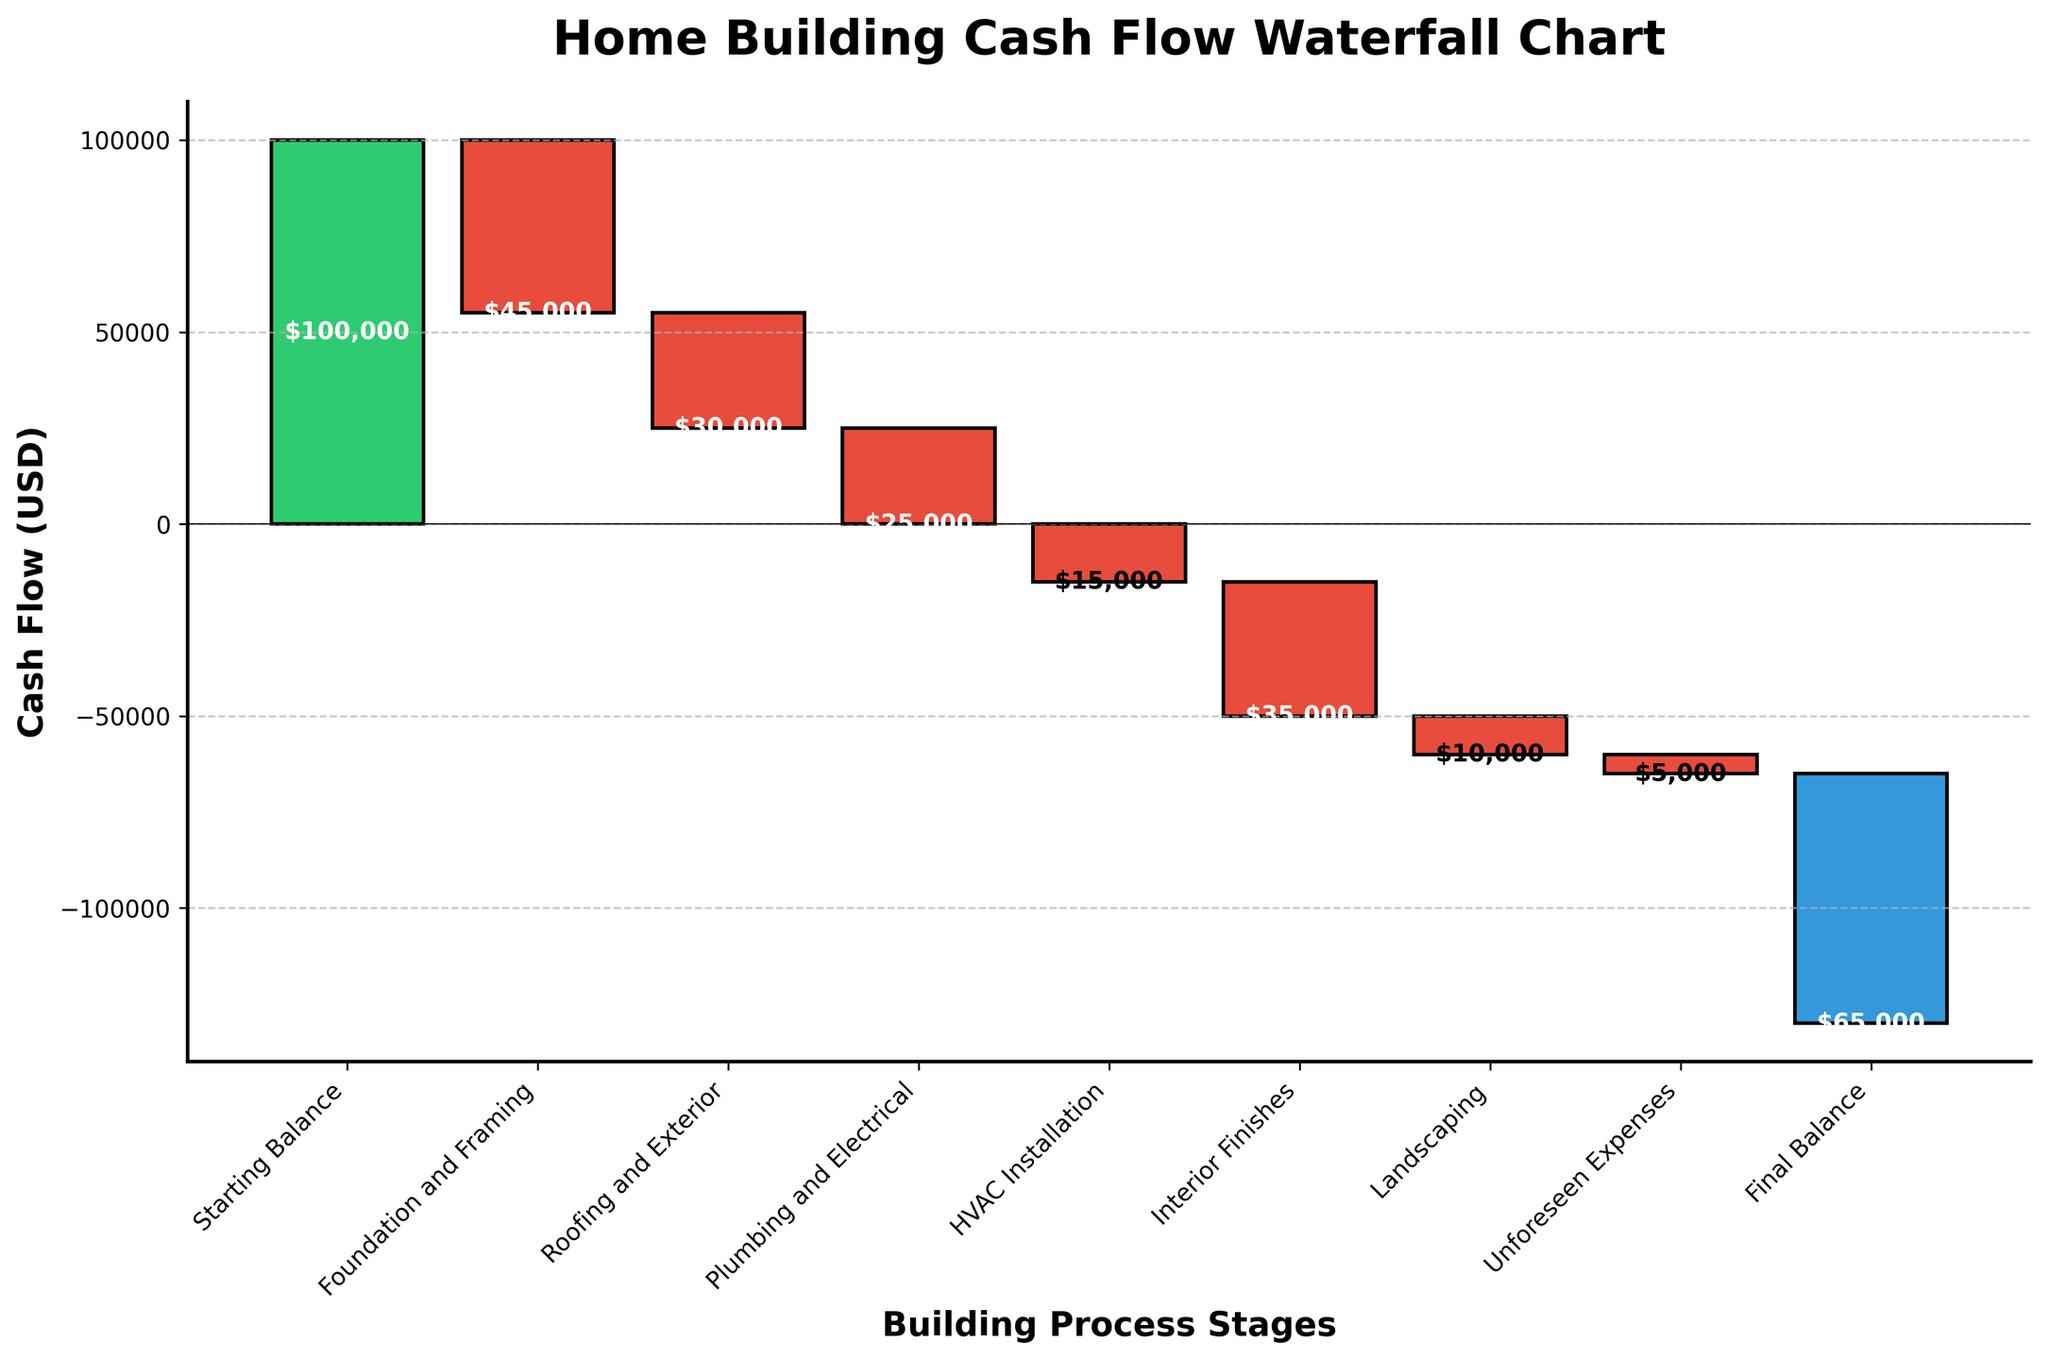What is the title of the chart? The title is located at the top of the chart and provides a description of the visual. By looking at the title, you can determine the main focus of the chart.
Answer: Home Building Cash Flow Waterfall Chart How many stages are there in the building process shown? The number of stages is represented by the different categories along the x-axis. Counting these categories will give us the total number of stages.
Answer: 9 Which stage resulted in the highest cash outflow? To find the highest cash outflow, identify the darkest red bar that extends down the most. This bar represents the highest expenditure stage.
Answer: Foundation and Framing What is the total cash outflow up to the Landscaping stage? To get the total cash outflow up to the Landscaping stage, sum the negative values up to this category: -45000 (Foundation and Framing) + -30000 (Roofing and Exterior) + -25000 (Plumbing and Electrical) + -15000 (HVAC Installation) + -35000 (Interior Finishes) + -10000 (Landscaping).
Answer: -160,000 What is the final balance after the home building process? The final balance can be found at the endpoint of the cumulative total line, represented by the color blue. This is the amount of cash remaining after all expenses.
Answer: -65,000 How does the Interior Finishes stage compare to the HVAC Installation stage in terms of cash outflow? Compare the cash outflow amounts for both stages by looking at the length of their respective red bars. The higher negative value indicates greater outflow.
Answer: Interior Finishes had a higher cash outflow Which stages have cash inflow, if any? Cash inflow is represented by green bars, as opposed to red bars for cash outflows. Identify any green-colored bars among the stages.
Answer: None What was the cumulative cash balance after Plumbing and Electrical work was completed? To determine the cumulative cash balance at this stage, sum the starting balance with the cash flows of each stage up to Plumbing and Electrical: 100000 (Starting Balance) - 45000 - 30000 - 25000.
Answer: 0 What percentage of the total expenditure does Foundation and Framing represent? Calculate the percentage by dividing the amount for Foundation and Framing by the total expenditure, then multiply by 100: (-45000 / 240000) * 100, where 240000 is the sum of all expenditures.
Answer: 18.75% 